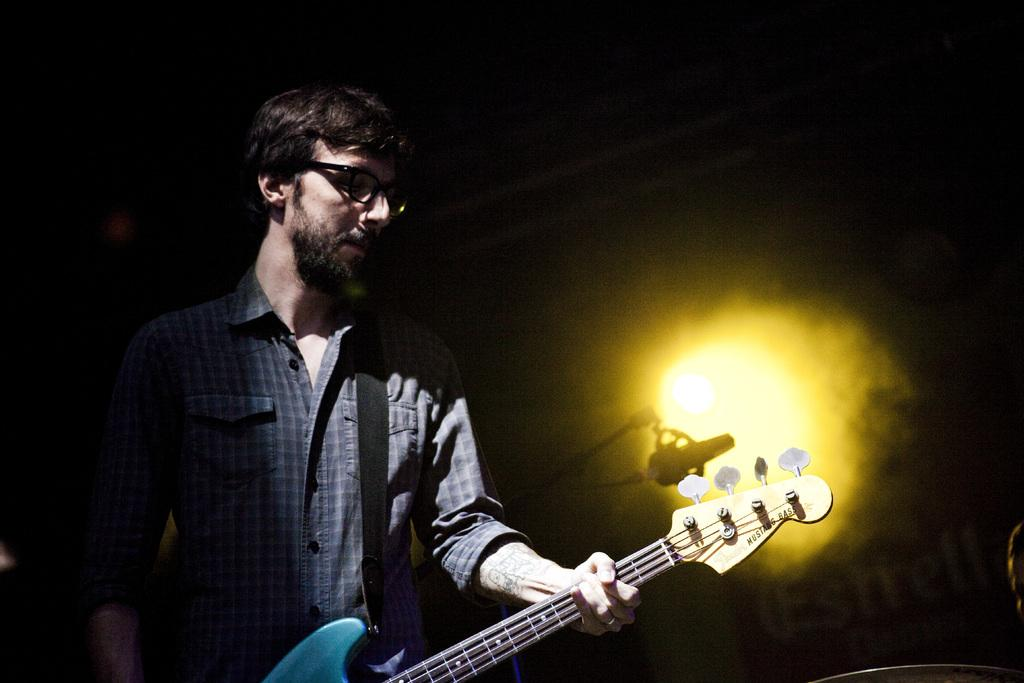Who is present in the image? There is a man in the image. What is the man wearing? The man is wearing a blue shirt. What is the man holding in the image? The man is holding a guitar. What accessory is the man wearing? The man is wearing glasses. What object is behind the man? There is a microphone behind the man. What can be seen in the background of the image? There is a big wall in the background. What is the man's sister doing in the image? There is no mention of a sister in the image or the provided facts. 